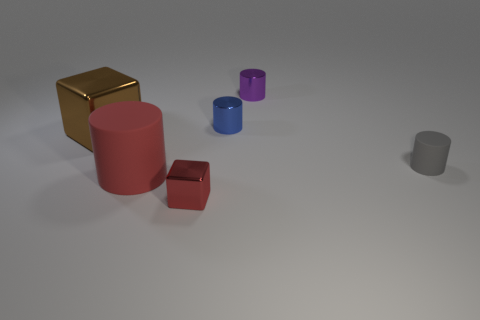There is a object that is the same color as the big matte cylinder; what material is it?
Keep it short and to the point. Metal. There is a tiny metallic thing that is behind the gray object and in front of the small purple thing; what is its shape?
Offer a very short reply. Cylinder. Are there any things that have the same material as the large cylinder?
Your answer should be compact. Yes. There is a cylinder that is the same color as the small cube; what is its size?
Offer a very short reply. Large. What color is the big object that is in front of the big block?
Offer a very short reply. Red. Is the shape of the brown shiny object the same as the tiny metal object that is in front of the brown metal thing?
Offer a terse response. Yes. Is there a metal thing that has the same color as the large rubber thing?
Provide a short and direct response. Yes. The brown cube that is made of the same material as the blue cylinder is what size?
Offer a very short reply. Large. Is the color of the large matte thing the same as the small block?
Offer a very short reply. Yes. There is a shiny object left of the red metallic object; is it the same shape as the red metal object?
Your answer should be very brief. Yes. 